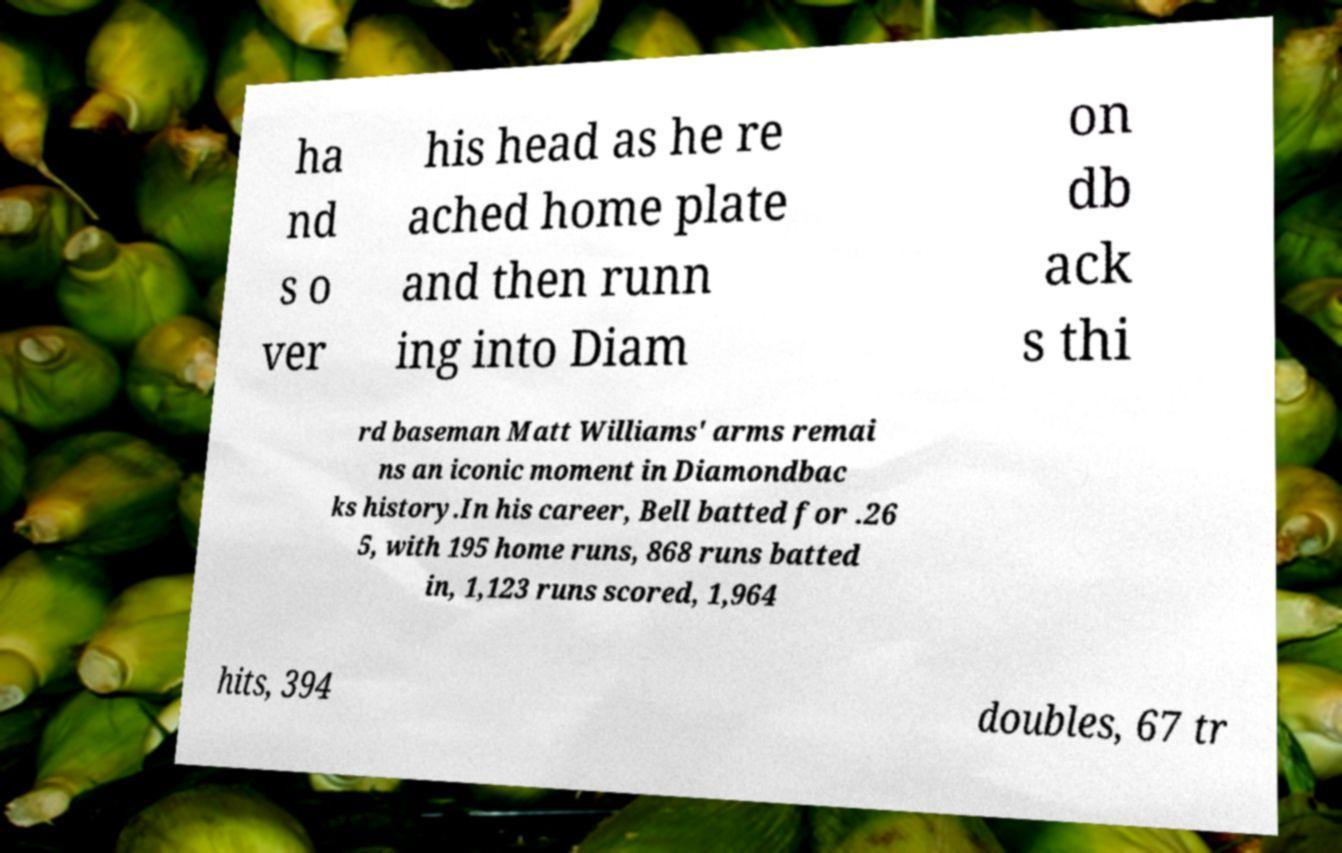There's text embedded in this image that I need extracted. Can you transcribe it verbatim? ha nd s o ver his head as he re ached home plate and then runn ing into Diam on db ack s thi rd baseman Matt Williams' arms remai ns an iconic moment in Diamondbac ks history.In his career, Bell batted for .26 5, with 195 home runs, 868 runs batted in, 1,123 runs scored, 1,964 hits, 394 doubles, 67 tr 